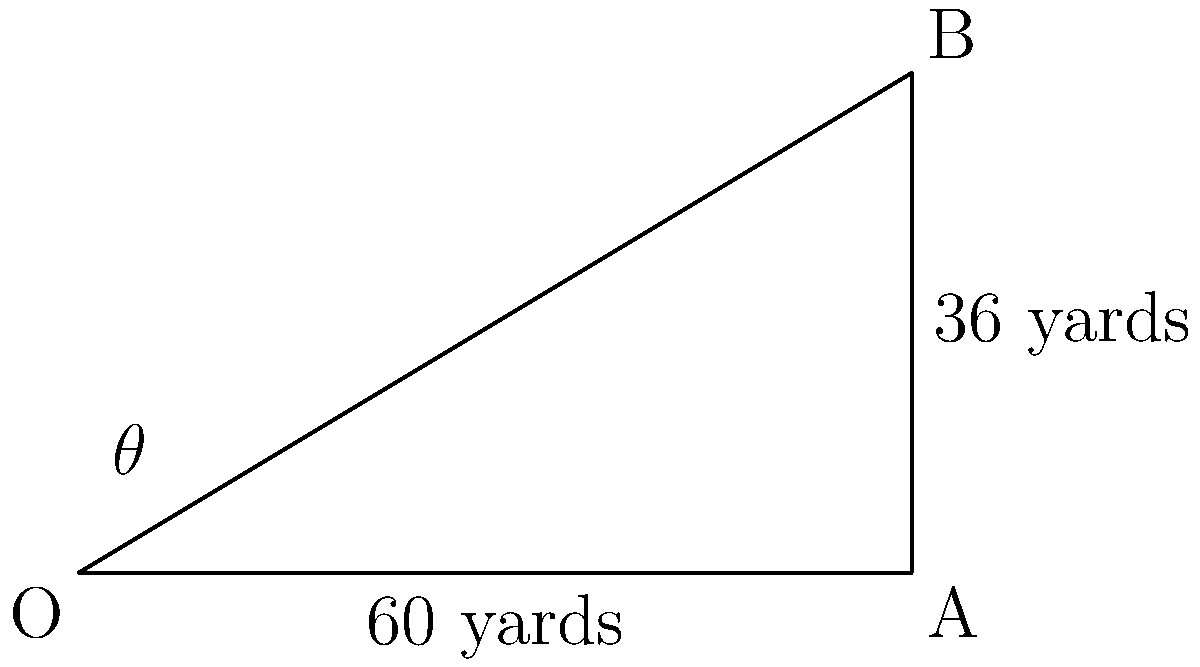During a crucial game, a quarterback throws a football that travels 60 yards horizontally and reaches a maximum height of 36 yards. Using trigonometry, calculate the angle $\theta$ at which the ball was thrown. Round your answer to the nearest degree. To solve this problem, we'll use trigonometry, specifically the tangent function. Let's approach this step-by-step:

1) In the diagram, we have a right triangle OAB, where:
   - OA represents the horizontal distance (60 yards)
   - AB represents the maximum height (36 yards)
   - $\theta$ is the angle we need to find

2) The tangent of an angle in a right triangle is the ratio of the opposite side to the adjacent side:

   $\tan(\theta) = \frac{\text{opposite}}{\text{adjacent}}$

3) In our case:
   $\tan(\theta) = \frac{AB}{OA} = \frac{36}{60}$

4) Simplify the fraction:
   $\tan(\theta) = \frac{3}{5} = 0.6$

5) To find $\theta$, we need to use the inverse tangent (arctan or $\tan^{-1}$):
   $\theta = \tan^{-1}(0.6)$

6) Using a calculator or trigonometric tables:
   $\theta \approx 30.96^\circ$

7) Rounding to the nearest degree:
   $\theta \approx 31^\circ$

Therefore, the quarterback threw the football at an angle of approximately 31 degrees.
Answer: $31^\circ$ 